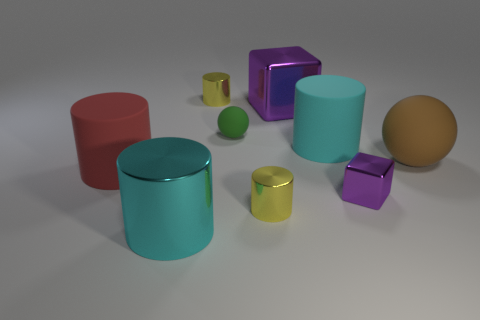Subtract all large cylinders. How many cylinders are left? 2 Subtract all spheres. How many objects are left? 7 Subtract all brown spheres. How many spheres are left? 1 Subtract 1 cubes. How many cubes are left? 1 Subtract all blue balls. Subtract all red blocks. How many balls are left? 2 Subtract all yellow cylinders. How many brown cubes are left? 0 Subtract all yellow metallic cylinders. Subtract all big red rubber things. How many objects are left? 6 Add 8 purple metallic blocks. How many purple metallic blocks are left? 10 Add 7 big green shiny cylinders. How many big green shiny cylinders exist? 7 Subtract 0 cyan blocks. How many objects are left? 9 